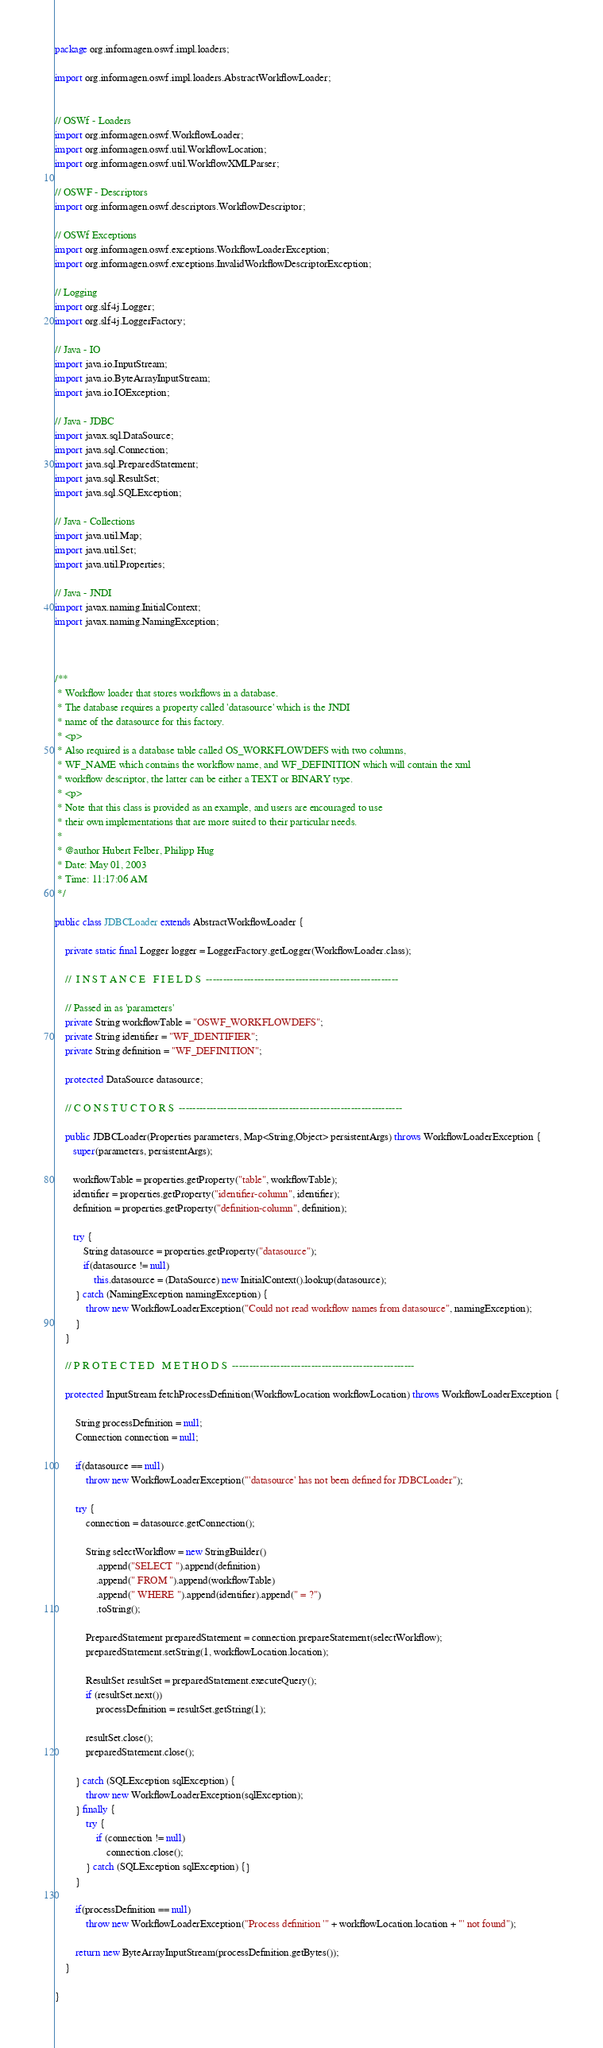Convert code to text. <code><loc_0><loc_0><loc_500><loc_500><_Java_>package org.informagen.oswf.impl.loaders;

import org.informagen.oswf.impl.loaders.AbstractWorkflowLoader;


// OSWf - Loaders
import org.informagen.oswf.WorkflowLoader;
import org.informagen.oswf.util.WorkflowLocation;
import org.informagen.oswf.util.WorkflowXMLParser;

// OSWF - Descriptors
import org.informagen.oswf.descriptors.WorkflowDescriptor;

// OSWf Exceptions
import org.informagen.oswf.exceptions.WorkflowLoaderException;
import org.informagen.oswf.exceptions.InvalidWorkflowDescriptorException;

// Logging
import org.slf4j.Logger;
import org.slf4j.LoggerFactory;

// Java - IO
import java.io.InputStream;
import java.io.ByteArrayInputStream;
import java.io.IOException;

// Java - JDBC
import javax.sql.DataSource;
import java.sql.Connection;
import java.sql.PreparedStatement;
import java.sql.ResultSet;
import java.sql.SQLException;

// Java - Collections
import java.util.Map;
import java.util.Set;
import java.util.Properties;

// Java - JNDI
import javax.naming.InitialContext;
import javax.naming.NamingException;



/**
 * Workflow loader that stores workflows in a database.
 * The database requires a property called 'datasource' which is the JNDI
 * name of the datasource for this factory.
 * <p>
 * Also required is a database table called OS_WORKFLOWDEFS with two columns,
 * WF_NAME which contains the workflow name, and WF_DEFINITION which will contain the xml
 * workflow descriptor, the latter can be either a TEXT or BINARY type.
 * <p>
 * Note that this class is provided as an example, and users are encouraged to use
 * their own implementations that are more suited to their particular needs.
 *
 * @author Hubert Felber, Philipp Hug
 * Date: May 01, 2003
 * Time: 11:17:06 AM
 */

public class JDBCLoader extends AbstractWorkflowLoader {

    private static final Logger logger = LoggerFactory.getLogger(WorkflowLoader.class);

    //  I N S T A N C E   F I E L D S  --------------------------------------------------------
    
    // Passed in as 'parameters'
    private String workflowTable = "OSWF_WORKFLOWDEFS";
    private String identifier = "WF_IDENTIFIER";
    private String definition = "WF_DEFINITION";

    protected DataSource datasource;
    
    // C O N S T U C T O R S  ----------------------------------------------------------------- 

    public JDBCLoader(Properties parameters, Map<String,Object> persistentArgs) throws WorkflowLoaderException {
       super(parameters, persistentArgs);
       
       workflowTable = properties.getProperty("table", workflowTable);
       identifier = properties.getProperty("identifier-column", identifier);
       definition = properties.getProperty("definition-column", definition);
              
       try {
           String datasource = properties.getProperty("datasource");
           if(datasource != null)
               this.datasource = (DataSource) new InitialContext().lookup(datasource);
        } catch (NamingException namingException) {
            throw new WorkflowLoaderException("Could not read workflow names from datasource", namingException);
        }
    }

    // P R O T E C T E D   M E T H O D S  -----------------------------------------------------

    protected InputStream fetchProcessDefinition(WorkflowLocation workflowLocation) throws WorkflowLoaderException {
 
        String processDefinition = null;
        Connection connection = null;
        
        if(datasource == null)
            throw new WorkflowLoaderException("'datasource' has not been defined for JDBCLoader");
        
        try {
            connection = datasource.getConnection();
            
            String selectWorkflow = new StringBuilder()
                .append("SELECT ").append(definition)
                .append(" FROM ").append(workflowTable)
                .append(" WHERE ").append(identifier).append(" = ?")
                .toString();

            PreparedStatement preparedStatement = connection.prepareStatement(selectWorkflow);
            preparedStatement.setString(1, workflowLocation.location);

            ResultSet resultSet = preparedStatement.executeQuery();
            if (resultSet.next()) 
                processDefinition = resultSet.getString(1);

            resultSet.close();
            preparedStatement.close();

        } catch (SQLException sqlException) {
            throw new WorkflowLoaderException(sqlException);            
        } finally {
            try {
                if (connection != null) 
                    connection.close();
            } catch (SQLException sqlException) {}
        }
        
        if(processDefinition == null)
            throw new WorkflowLoaderException("Process definition '" + workflowLocation.location + "' not found");
        
        return new ByteArrayInputStream(processDefinition.getBytes());
    }

}
</code> 